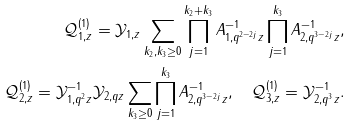Convert formula to latex. <formula><loc_0><loc_0><loc_500><loc_500>\mathcal { Q } ^ { ( 1 ) } _ { 1 , z } = \mathcal { Y } _ { 1 , z } \sum _ { k _ { 2 } , k _ { 3 } \geq 0 } \prod ^ { k _ { 2 } + k _ { 3 } } _ { j = 1 } A ^ { - 1 } _ { 1 , q ^ { 2 - 2 j } z } \prod ^ { k _ { 3 } } _ { j = 1 } A ^ { - 1 } _ { 2 , q ^ { 3 - 2 j } z } , \\ \mathcal { Q } ^ { ( 1 ) } _ { 2 , z } = \mathcal { Y } ^ { - 1 } _ { 1 , q ^ { 2 } z } \mathcal { Y } _ { 2 , q z } \sum _ { k _ { 3 } \geq 0 } \prod ^ { k _ { 3 } } _ { j = 1 } A ^ { - 1 } _ { 2 , q ^ { 3 - 2 j } z } , \quad \mathcal { Q } ^ { ( 1 ) } _ { 3 , z } = \mathcal { Y } ^ { - 1 } _ { 2 , q ^ { 3 } z } .</formula> 